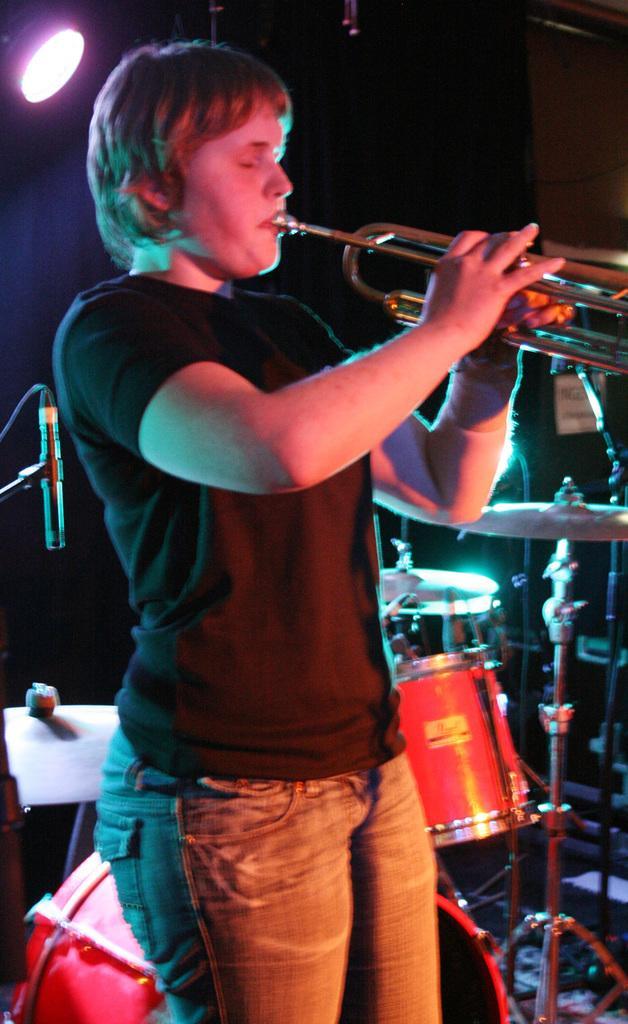In one or two sentences, can you explain what this image depicts? There is a person playing a trumpet. In the back there is a musical instrument. Also there is light and a mic with mic stand. 